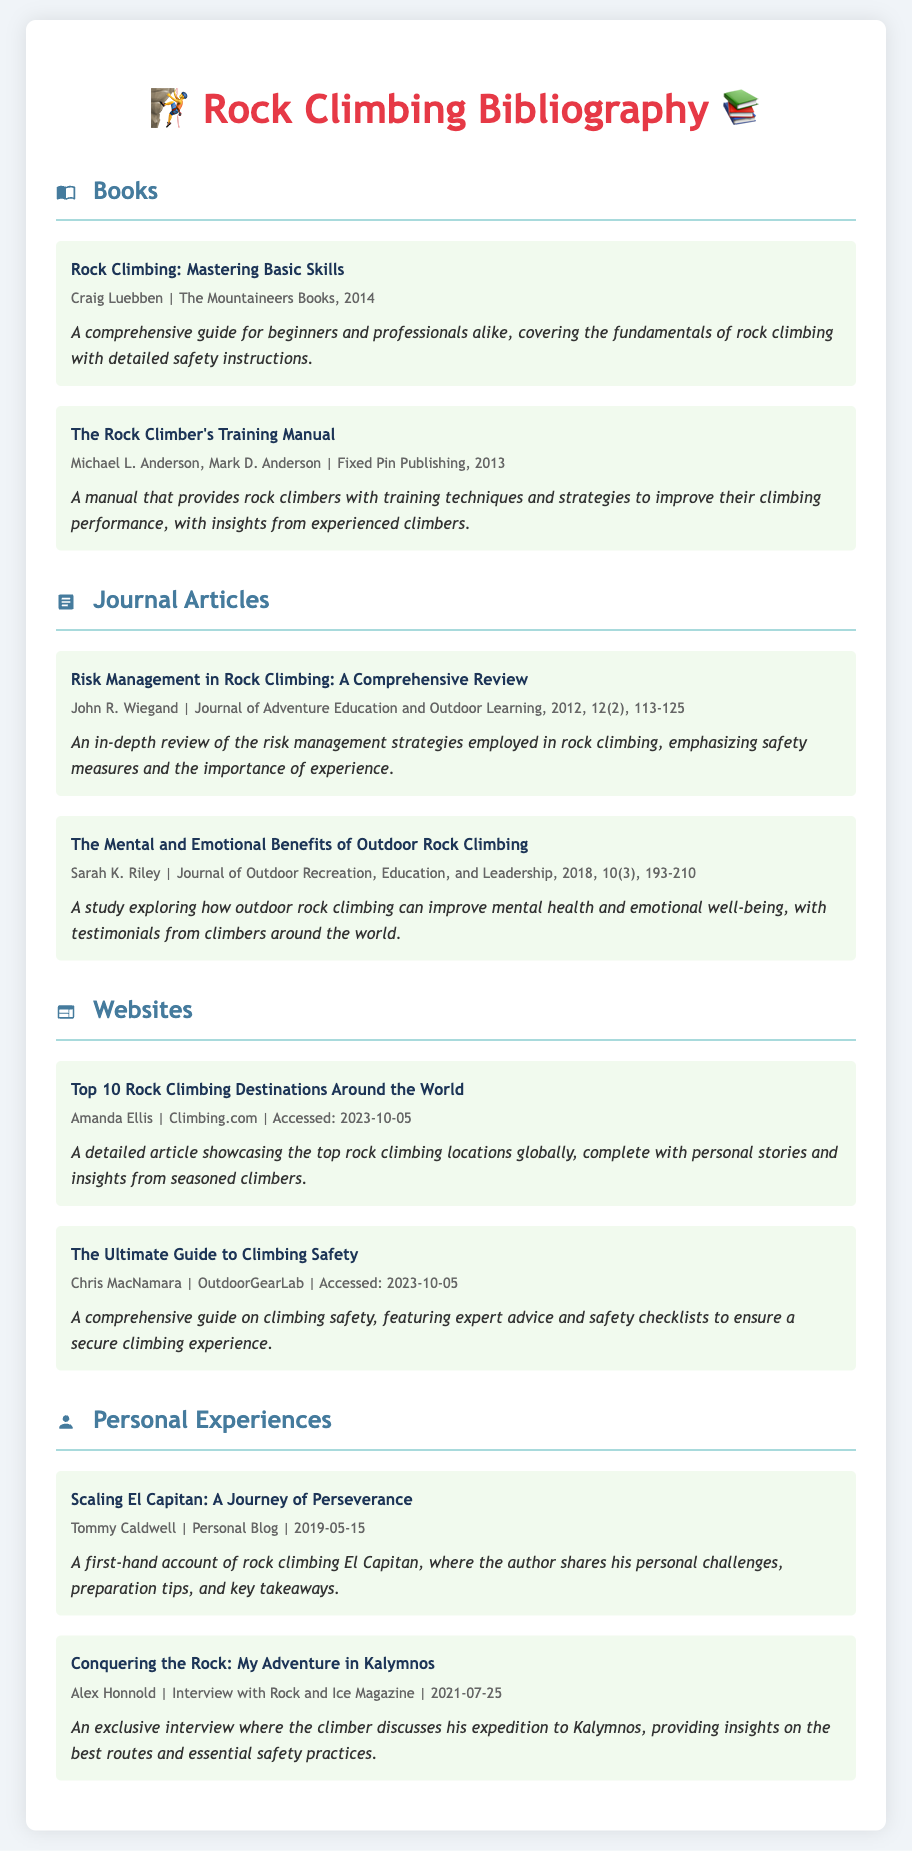What is the title of the first book listed? The title of the first book is the first entry under the "Books" section of the bibliography.
Answer: Rock Climbing: Mastering Basic Skills Who is the author of "The Mental and Emotional Benefits of Outdoor Rock Climbing"? This information can be found in the entry details of the article in the bibliography.
Answer: Sarah K. Riley What year was "The Rock Climber's Training Manual" published? The publication year is stated in the entry details for that book.
Answer: 2013 What is the main focus of the article by John R. Wiegand? This can be determined from the description provided in the entry about the journal article.
Answer: Risk management strategies in rock climbing How many entries are listed under "Websites"? This can be calculated by counting the entries in the "Websites" section of the bibliography.
Answer: 2 What is the personal blog title related to climbing mentioned in the document? The title is the first entry under the "Personal Experiences" section of the bibliography.
Answer: Scaling El Capitan: A Journey of Perseverance Who wrote the article on climbing safety? The author's name is included in the entry details under the "Websites" section.
Answer: Chris MacNamara What format is the bibliography presented in? The document provides a structured list of entries categorized by type, which is typical for bibliographies.
Answer: Structured list What type of information does the "entry-description" provide? The description typically summarizes the content or focus of each listed entry in the bibliography.
Answer: Summary of content 